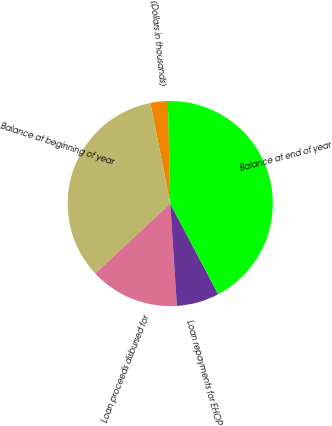Convert chart to OTSL. <chart><loc_0><loc_0><loc_500><loc_500><pie_chart><fcel>(Dollars in thousands)<fcel>Balance at beginning of year<fcel>Loan proceeds disbursed for<fcel>Loan repayments for EHOP<fcel>Balance at end of year<nl><fcel>2.74%<fcel>33.84%<fcel>14.09%<fcel>6.72%<fcel>42.61%<nl></chart> 